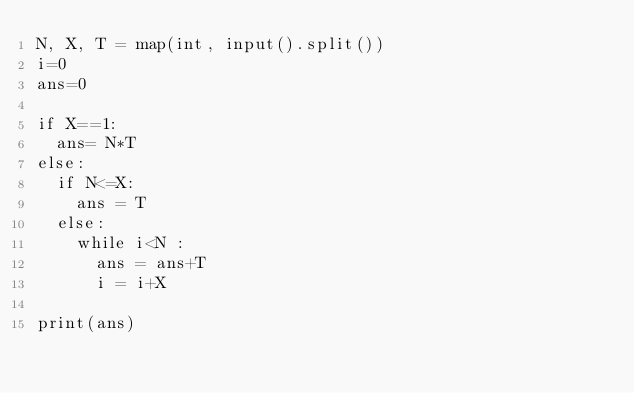<code> <loc_0><loc_0><loc_500><loc_500><_Python_>N, X, T = map(int, input().split())
i=0
ans=0

if X==1:
  ans= N*T
else:
  if N<=X:
    ans = T
  else:
    while i<N :
      ans = ans+T 
      i = i+X

print(ans)



</code> 